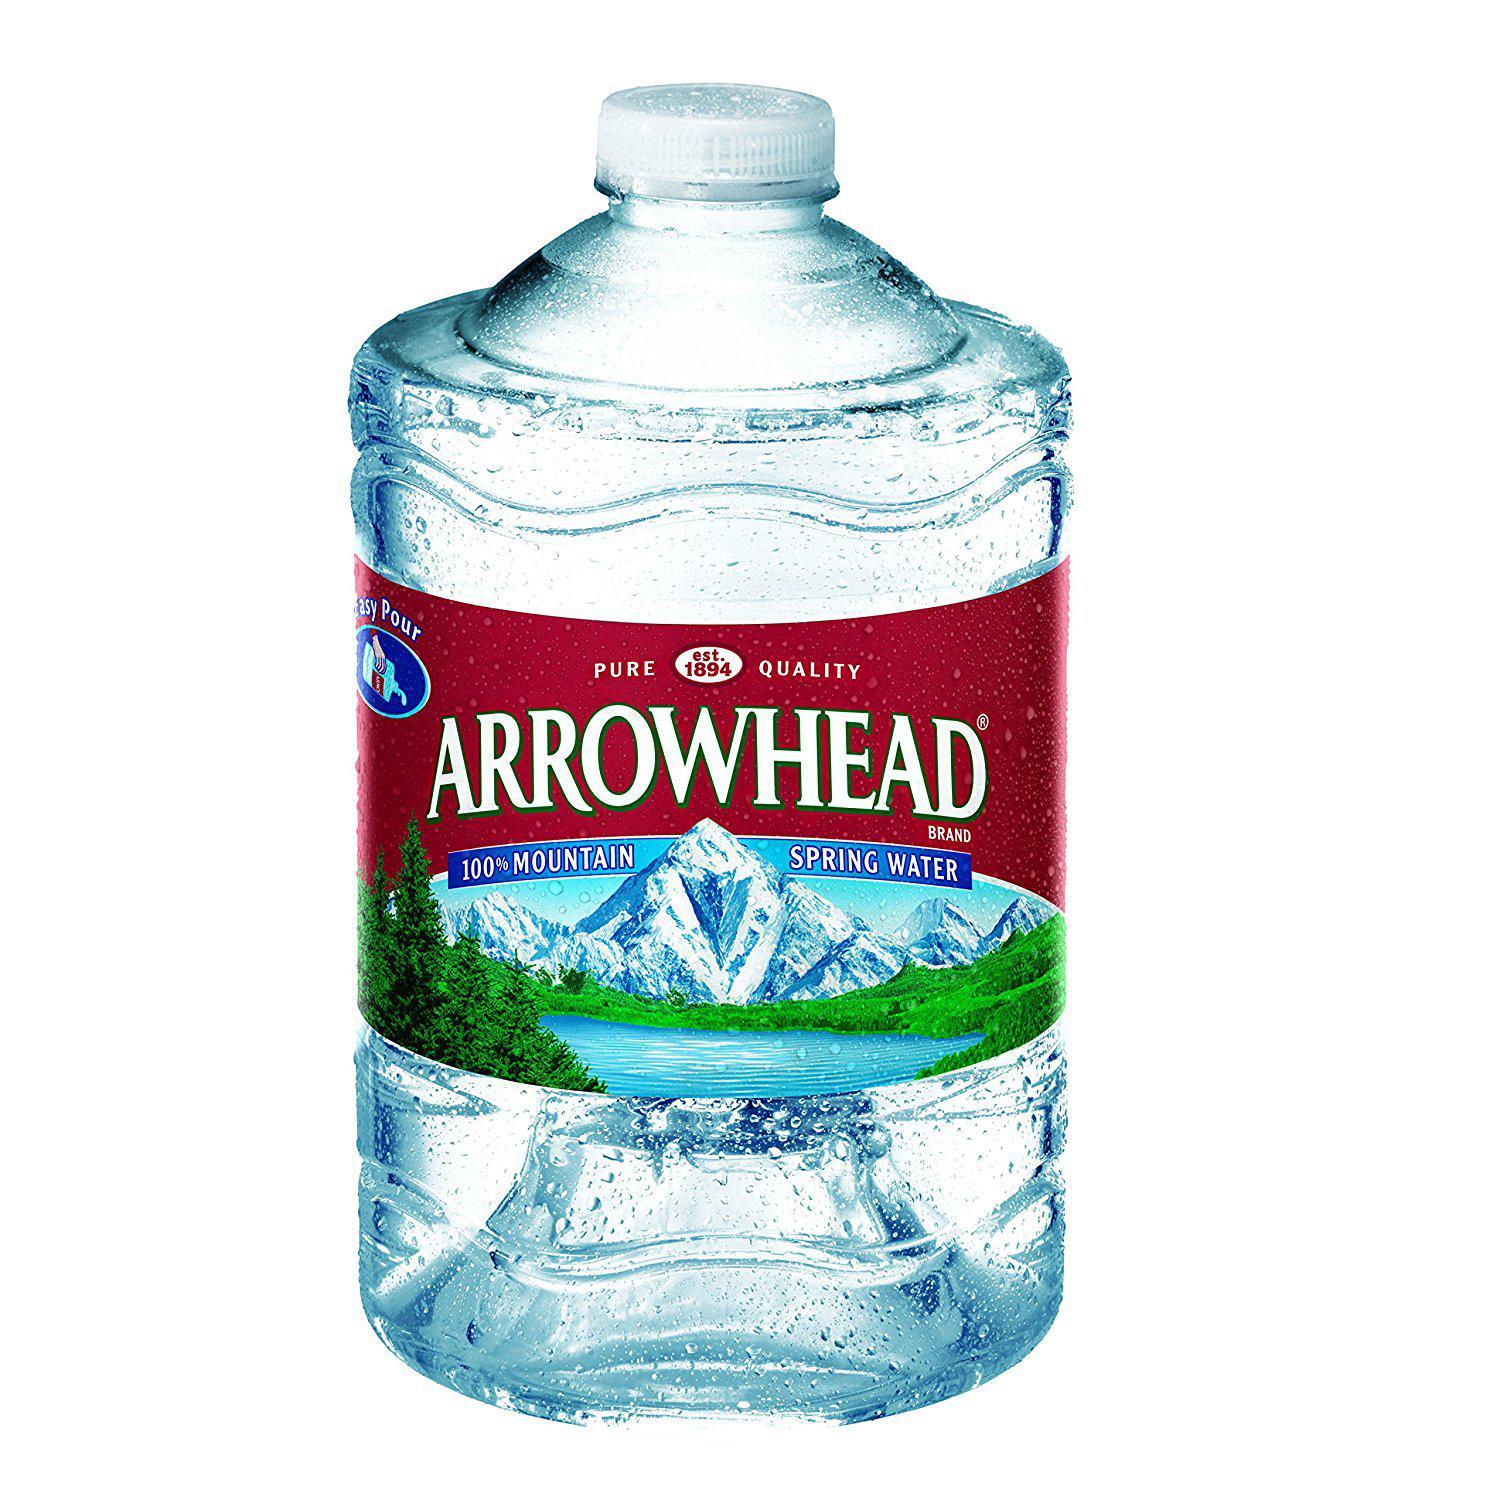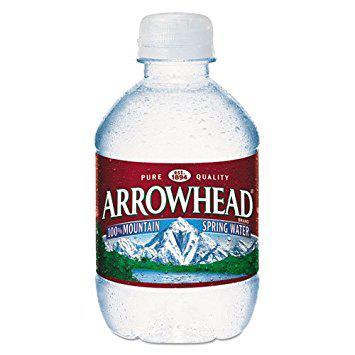The first image is the image on the left, the second image is the image on the right. Evaluate the accuracy of this statement regarding the images: "Right and left images show a similarly shaped and sized non-stout bottle with a label and a white cap.". Is it true? Answer yes or no. No. The first image is the image on the left, the second image is the image on the right. Analyze the images presented: Is the assertion "There are two nearly identical bottles of water." valid? Answer yes or no. No. 